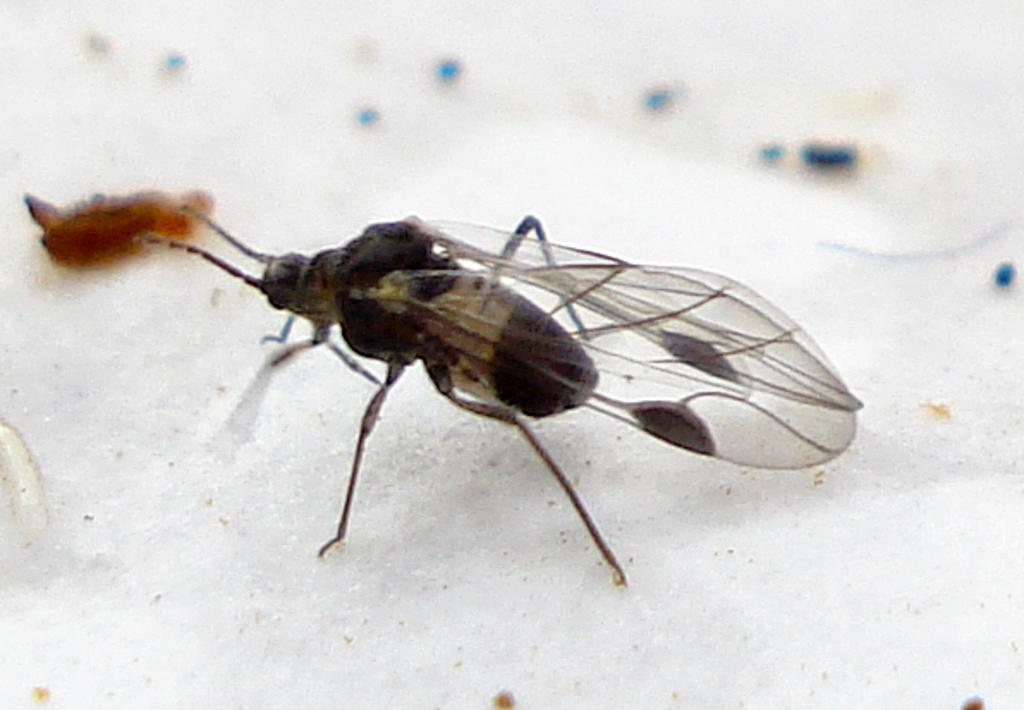What type of creature is present in the image? There is an insect in the image. What else can be seen in the image besides the insect? There are other things in the image. What color is the surface on which the insect and other items are placed? The surface in the image is white. Who is the creator of the insect in the image? The facts provided do not mention a creator for the insect, and it is not possible to determine who created it from the image alone. 